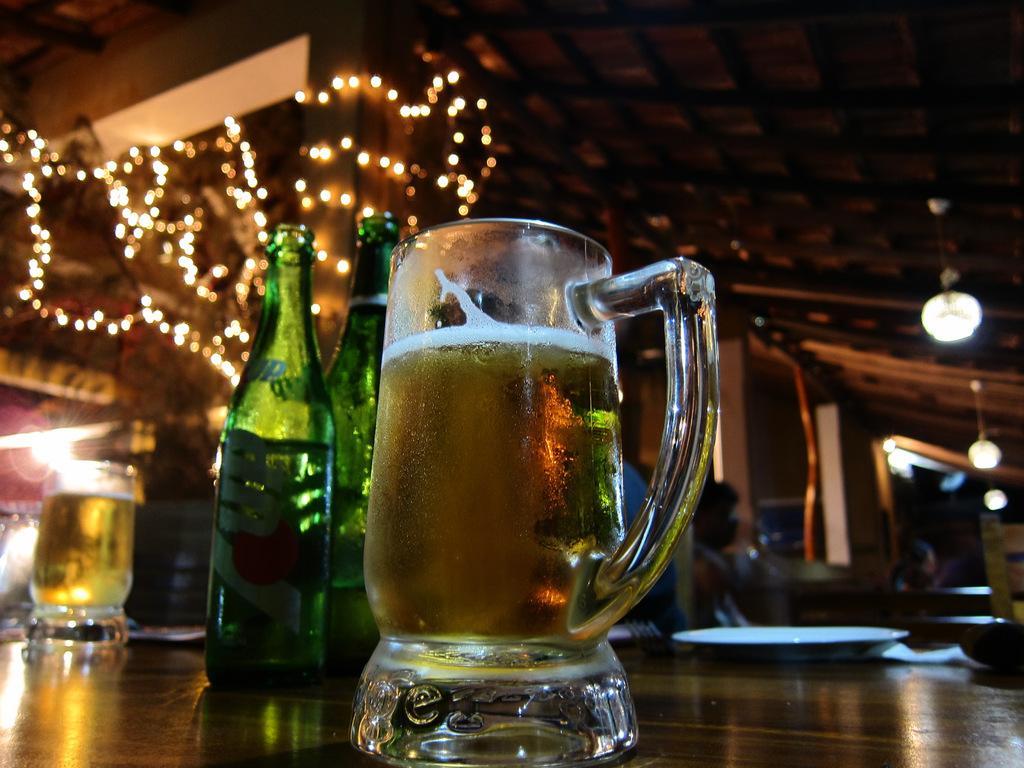In one or two sentences, can you explain what this image depicts? In the picture we can see a wooden table on it, we can see a glass of wine and beside we can see some wine bottles which are green in color and in the background we can see a house which is decorated with lights. 